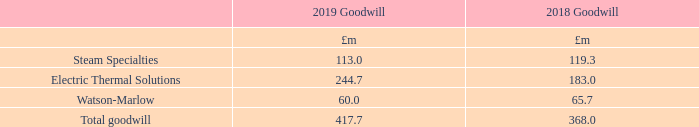15 Goodwill and other intangible assets continued
Impairment
In accordance with the requirements of IAS 36 (Impairment of Assets), goodwill is allocated to the Group’s cash-generating units, or groups of cash-generating units, that are expected to benefit from the synergies of the business combination that gave rise to the goodwill.
During 2019, we performed a review on the basis of identification of our individual CGUs. As a result of this review, we have consolidated a number of our current individual CGUs into groups of CGUs that represent the lowest level to which goodwill is monitored for internal management purposes, being each operating segment as disclosed in Note 3. As a result, we performed an impairment review at an operating segment CGU level, the breakdown of the goodwill value at 31st December across these is shown below:
In order to complete the transition to performing goodwill impairment reviews at an operating segment level, we also performed a goodwill impairment review as at 31st December 2019 under the historical CGU basis. The result of this impairment review led to an impairment of £4.2m being recognised in respect of Watson-Marlow FlowSmart. No other impairment was recognised.
The goodwill balance has been tested for annual impairment on the following basis:
• the carrying values of goodwill have been assessed by reference to value in use. These have been estimated using cash flows based on forecast information for the next financial year which have been approved by the Board and then extended up to a further 9 years based on the most recent forecasts prepared by management; • pre-tax discount rates range from 11-12% (2018: 10-15%); • short to medium-term growth rates vary between 3-8% depending on detailed forecasts (2018: 2-8%). The range in rates excludes the annualised impact of owning Thermocoax for a first full year in 2020. The short to medium-term is defined as not more than 10 years; and • long-term growth rates are set using IMF forecasts and vary between 1.8-2.5% (2018: 0.8-3.0%).
What was consolidated as a result of the review on the basis of identification of the individual CGUs? A number of our current individual cgus into groups of cgus that represent the lowest level to which goodwill is monitored for internal management purposes, being each operating segment as disclosed in note 3. How are the carrying values of goodwill estimated? Using cash flows based on forecast information for the next financial year which have been approved by the board and then extended up to a further 9 years based on the most recent forecasts prepared by management. What are the different operating segment as part of the goodwill impairment reviews? Steam specialties, electric thermal solutions, watson-marlow. In which year was the amount of Goodwill for Watson-Marlow larger? 65.7>60.0
Answer: 2018. What was the change in total goodwill in 2019 from 2018?
Answer scale should be: million. 417.7-368.0
Answer: 49.7. What was the percentage change in total goodwill in 2019 from 2018?
Answer scale should be: percent. (417.7-368.0)/368.0
Answer: 13.51. 